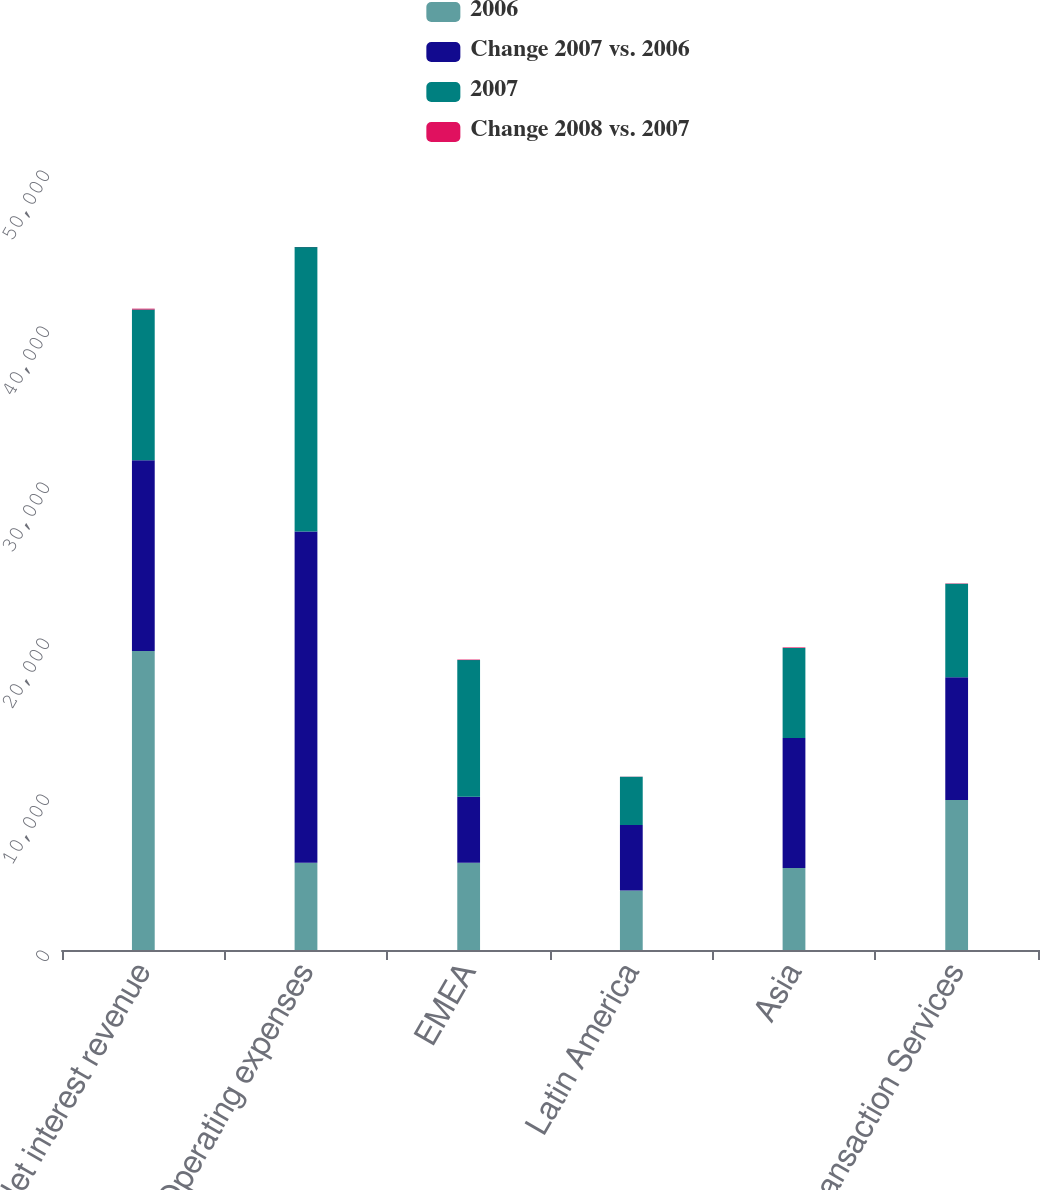Convert chart. <chart><loc_0><loc_0><loc_500><loc_500><stacked_bar_chart><ecel><fcel>Net interest revenue<fcel>Operating expenses<fcel>EMEA<fcel>Latin America<fcel>Asia<fcel>Transaction Services<nl><fcel>2006<fcel>19159<fcel>5592<fcel>5592<fcel>3812<fcel>5256<fcel>9620<nl><fcel>Change 2007 vs. 2006<fcel>12242<fcel>21236<fcel>4235<fcel>4206<fcel>8339<fcel>7865<nl><fcel>2007<fcel>9653<fcel>18229<fcel>8758<fcel>3091<fcel>5766<fcel>5996<nl><fcel>Change 2008 vs. 2007<fcel>57<fcel>8<fcel>32<fcel>9<fcel>37<fcel>22<nl></chart> 